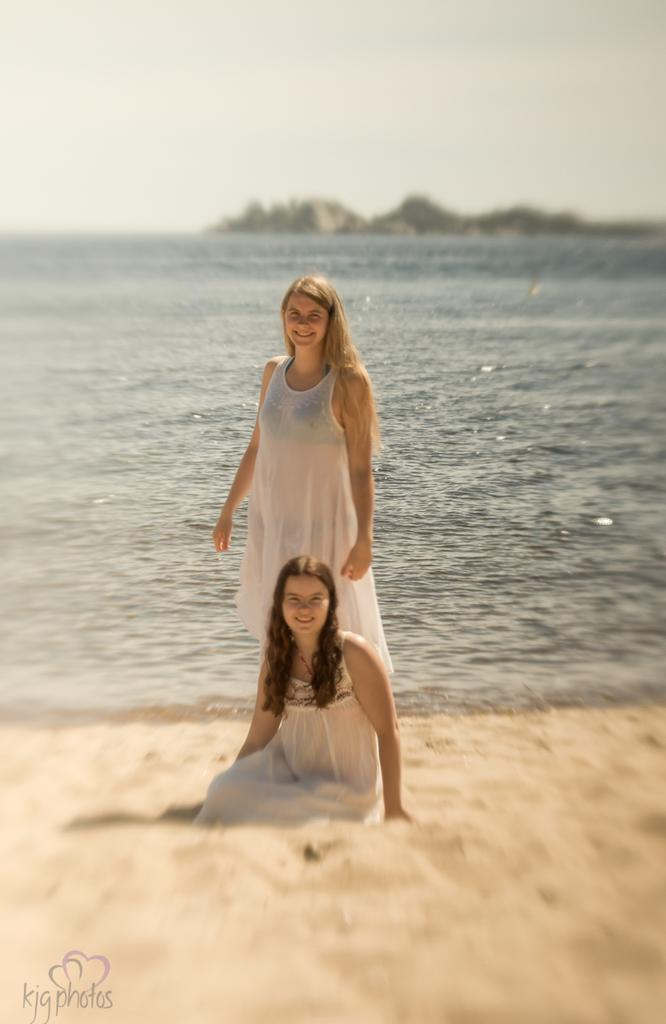What type of natural environment is depicted in the image? The image contains water and sand, which suggests a beach or coastal setting. How many women are present in the image? There are two women in the image. What are the women wearing? The women are wearing white dresses. What is visible at the top of the image? The sky is visible at the top of the image. How many cows can be seen grazing on the plate in the image? There are no cows or plates present in the image. What type of boats are visible in the image? There are no boats visible in the image. 